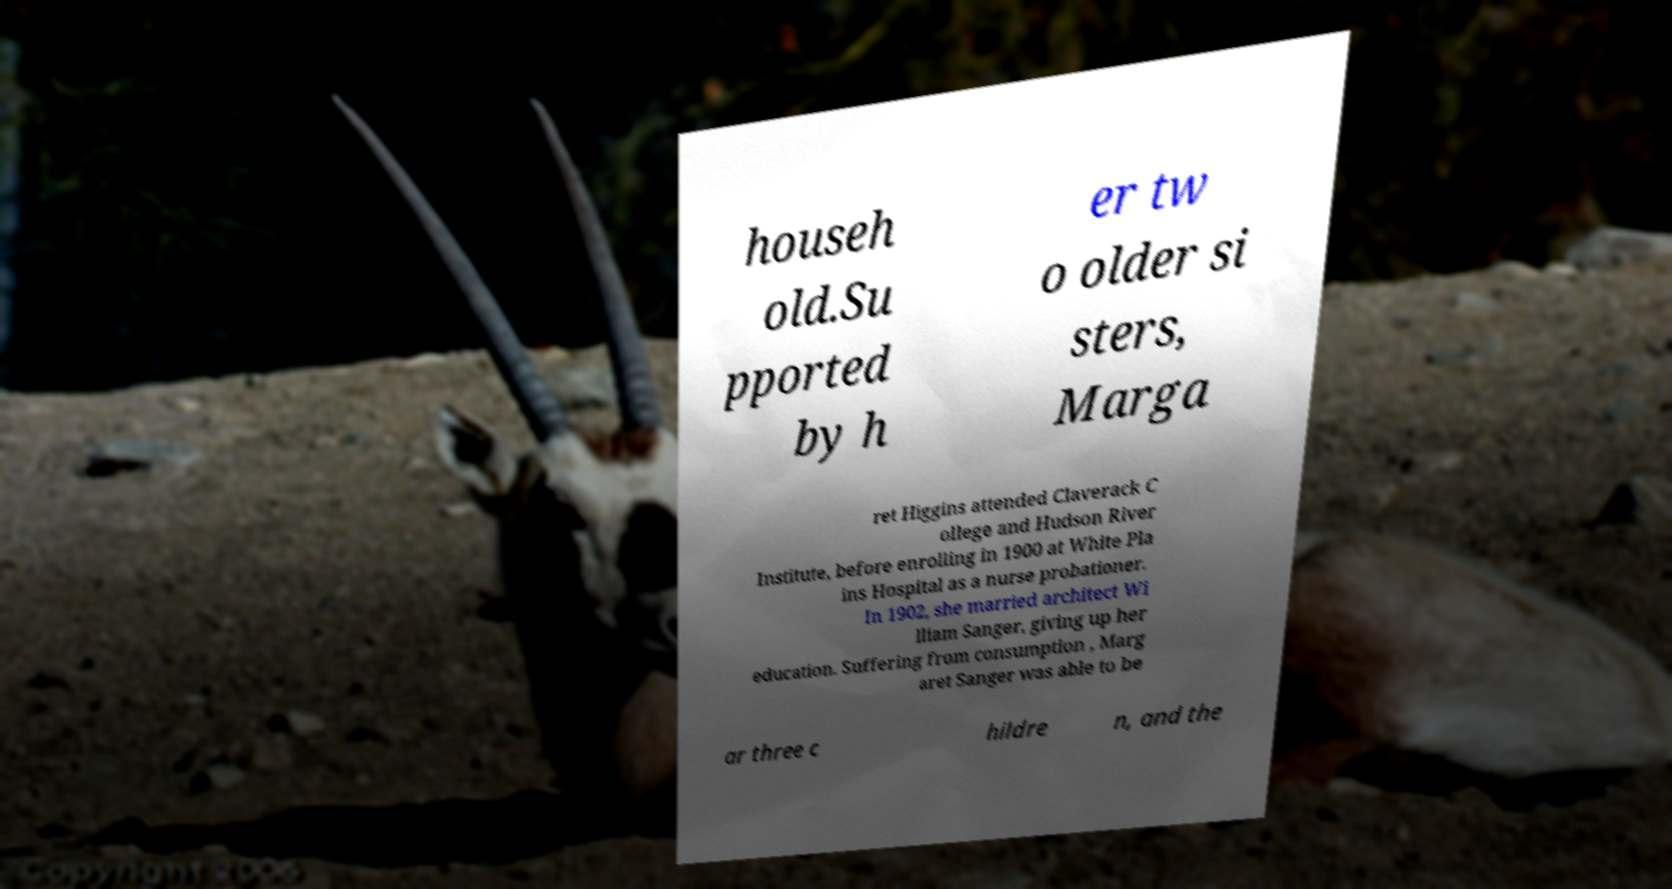Can you read and provide the text displayed in the image?This photo seems to have some interesting text. Can you extract and type it out for me? househ old.Su pported by h er tw o older si sters, Marga ret Higgins attended Claverack C ollege and Hudson River Institute, before enrolling in 1900 at White Pla ins Hospital as a nurse probationer. In 1902, she married architect Wi lliam Sanger, giving up her education. Suffering from consumption , Marg aret Sanger was able to be ar three c hildre n, and the 